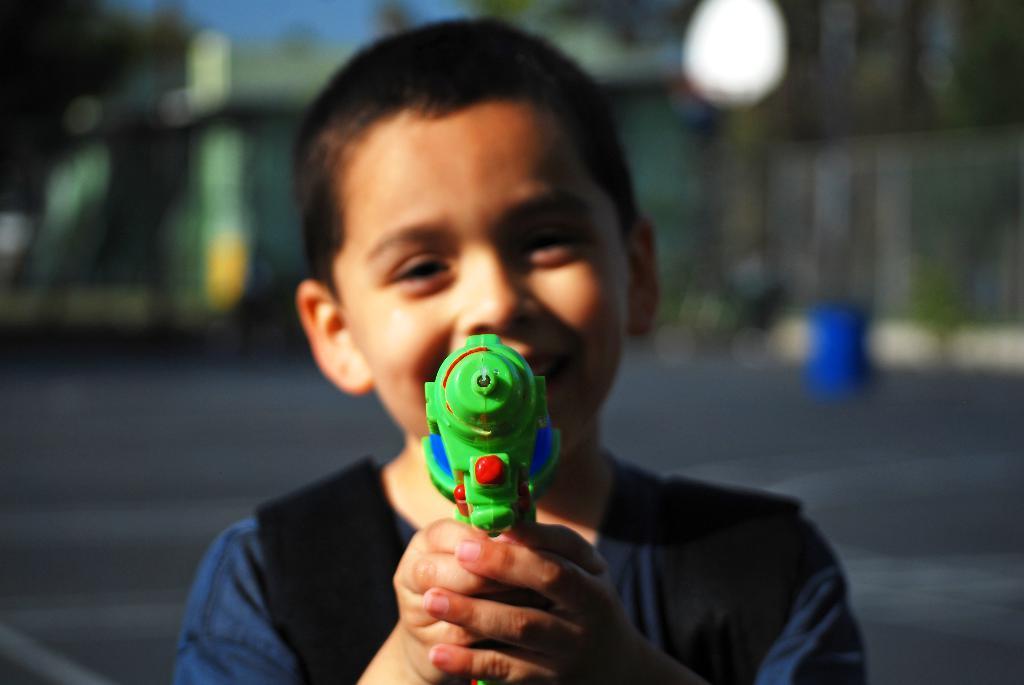Please provide a concise description of this image. In this image we can see a boy holding toy in his hands. In the background there are road, trees and sky. 